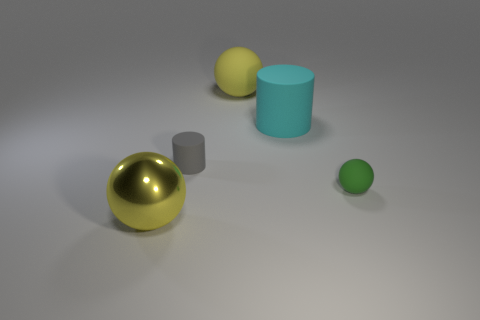What might be the purpose of this arrangement? The purpose of this arrangement may be for artistic display, educational demonstration of shape and shadow, or perhaps a simple 3D rendering test for materials and lighting. It gives a viewer a chance to observe how light interacts with objects of different colors and textures. 